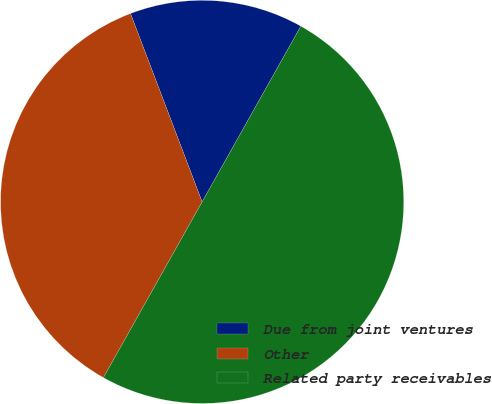Convert chart to OTSL. <chart><loc_0><loc_0><loc_500><loc_500><pie_chart><fcel>Due from joint ventures<fcel>Other<fcel>Related party receivables<nl><fcel>13.93%<fcel>36.07%<fcel>50.0%<nl></chart> 